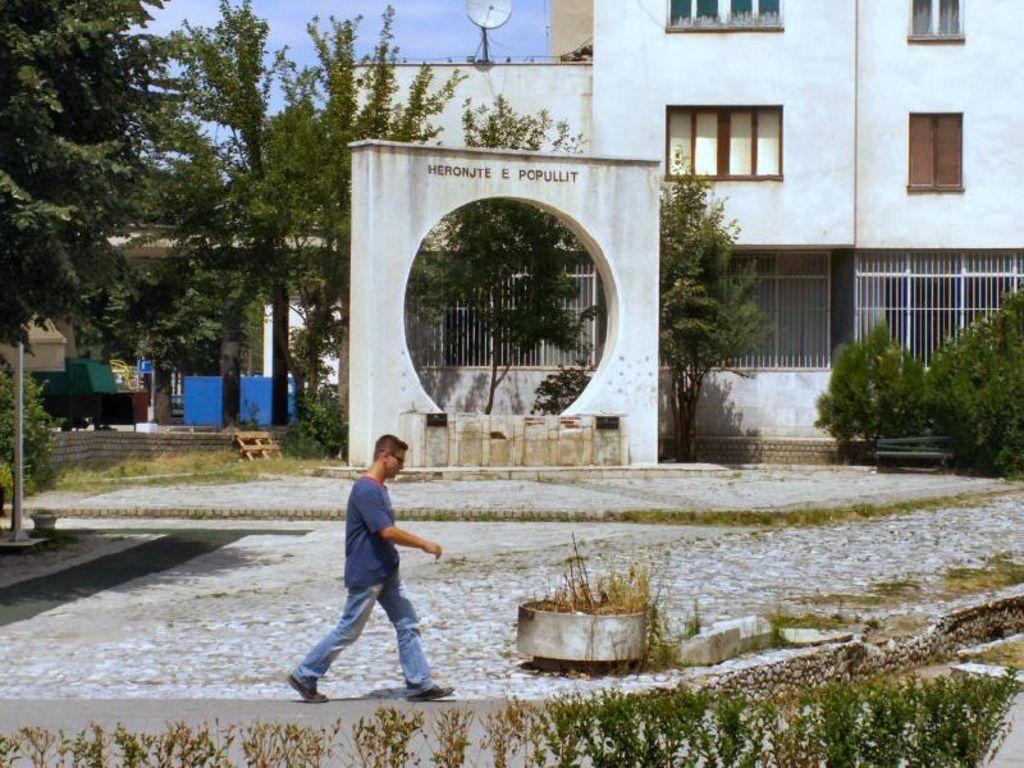In one or two sentences, can you explain what this image depicts? In this image there is a person walking, plants, grass, bench, buildings, pole, antenna,trees,sky. 